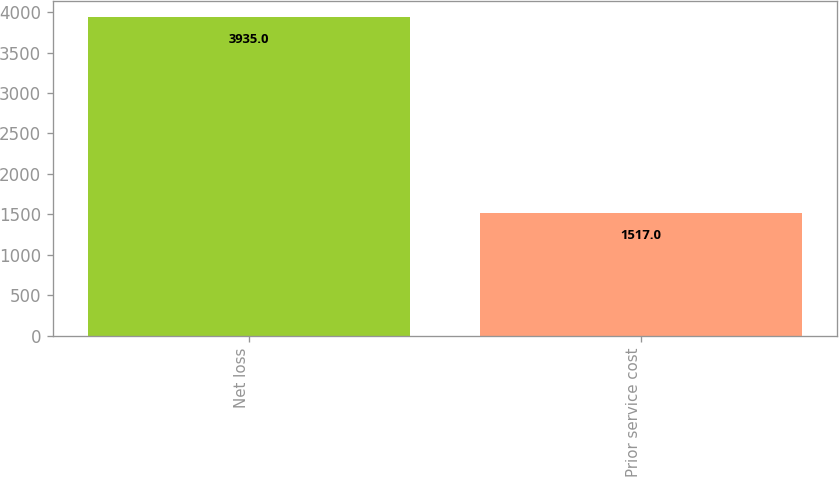<chart> <loc_0><loc_0><loc_500><loc_500><bar_chart><fcel>Net loss<fcel>Prior service cost<nl><fcel>3935<fcel>1517<nl></chart> 